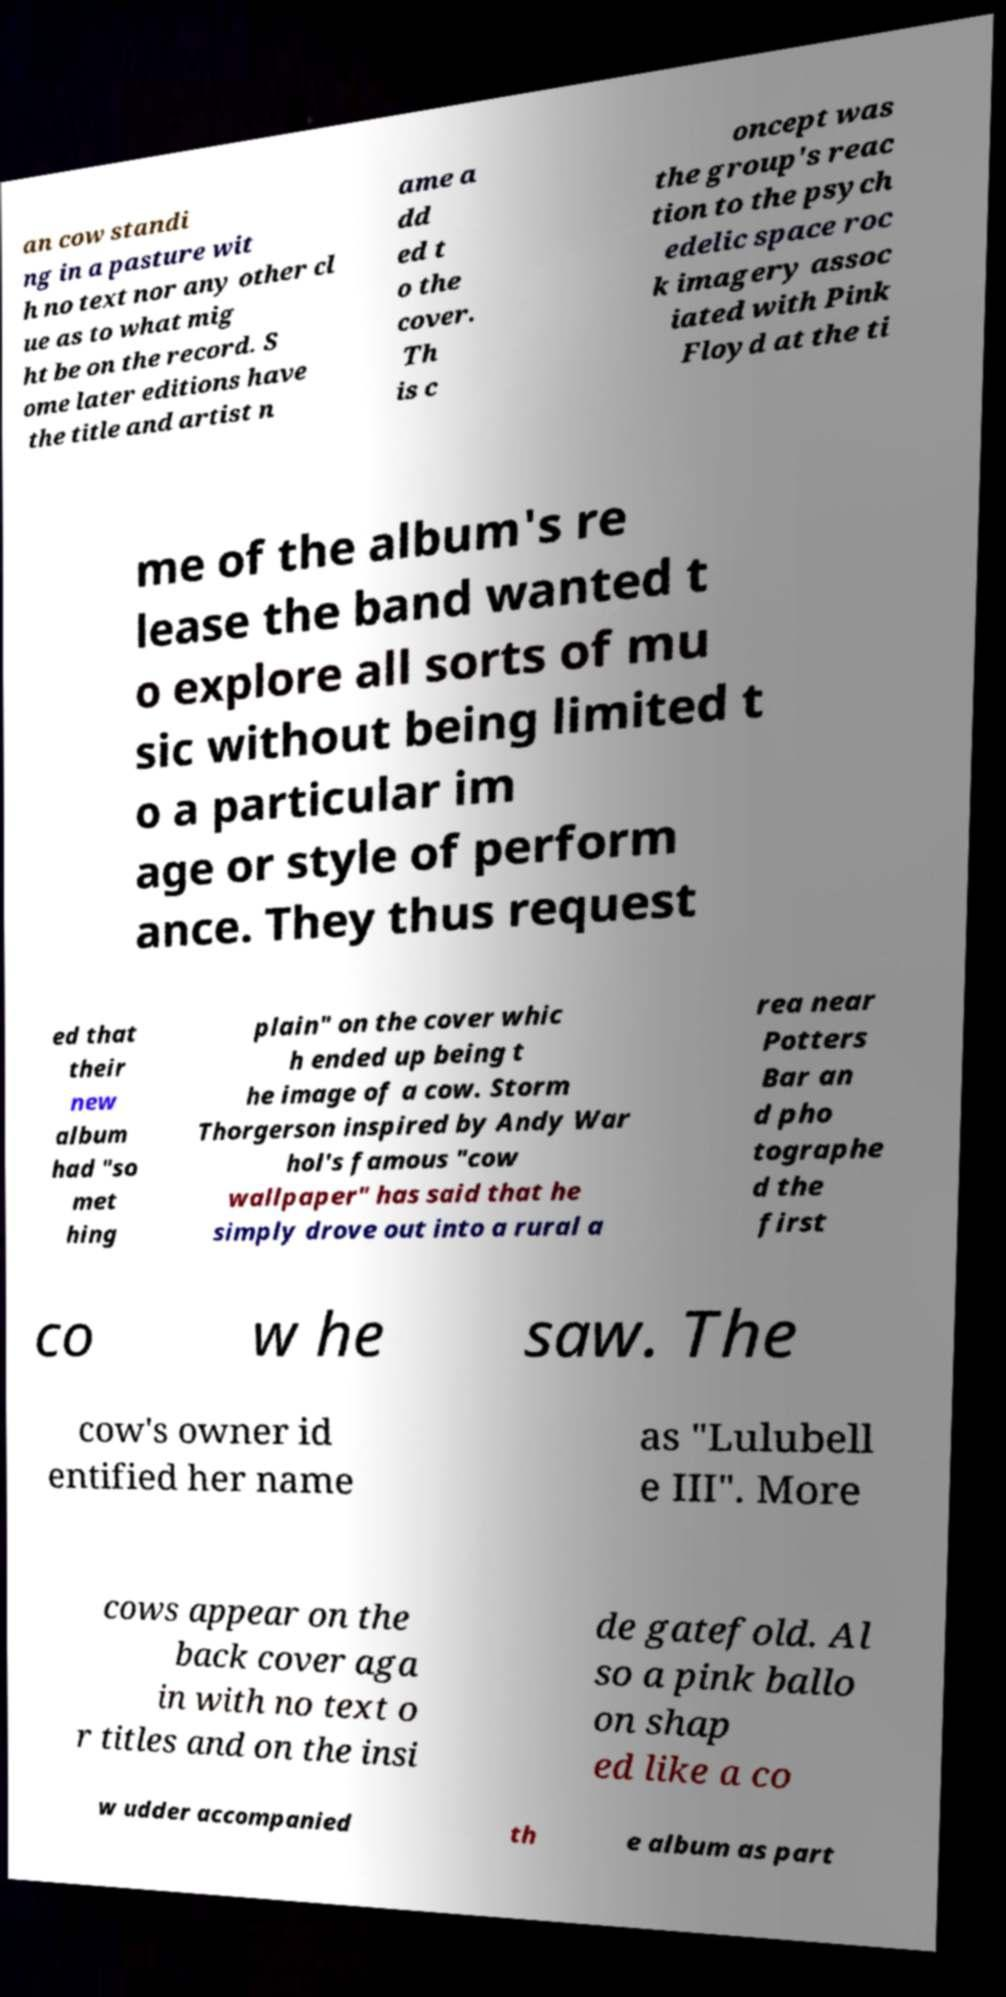Please read and relay the text visible in this image. What does it say? an cow standi ng in a pasture wit h no text nor any other cl ue as to what mig ht be on the record. S ome later editions have the title and artist n ame a dd ed t o the cover. Th is c oncept was the group's reac tion to the psych edelic space roc k imagery assoc iated with Pink Floyd at the ti me of the album's re lease the band wanted t o explore all sorts of mu sic without being limited t o a particular im age or style of perform ance. They thus request ed that their new album had "so met hing plain" on the cover whic h ended up being t he image of a cow. Storm Thorgerson inspired by Andy War hol's famous "cow wallpaper" has said that he simply drove out into a rural a rea near Potters Bar an d pho tographe d the first co w he saw. The cow's owner id entified her name as "Lulubell e III". More cows appear on the back cover aga in with no text o r titles and on the insi de gatefold. Al so a pink ballo on shap ed like a co w udder accompanied th e album as part 